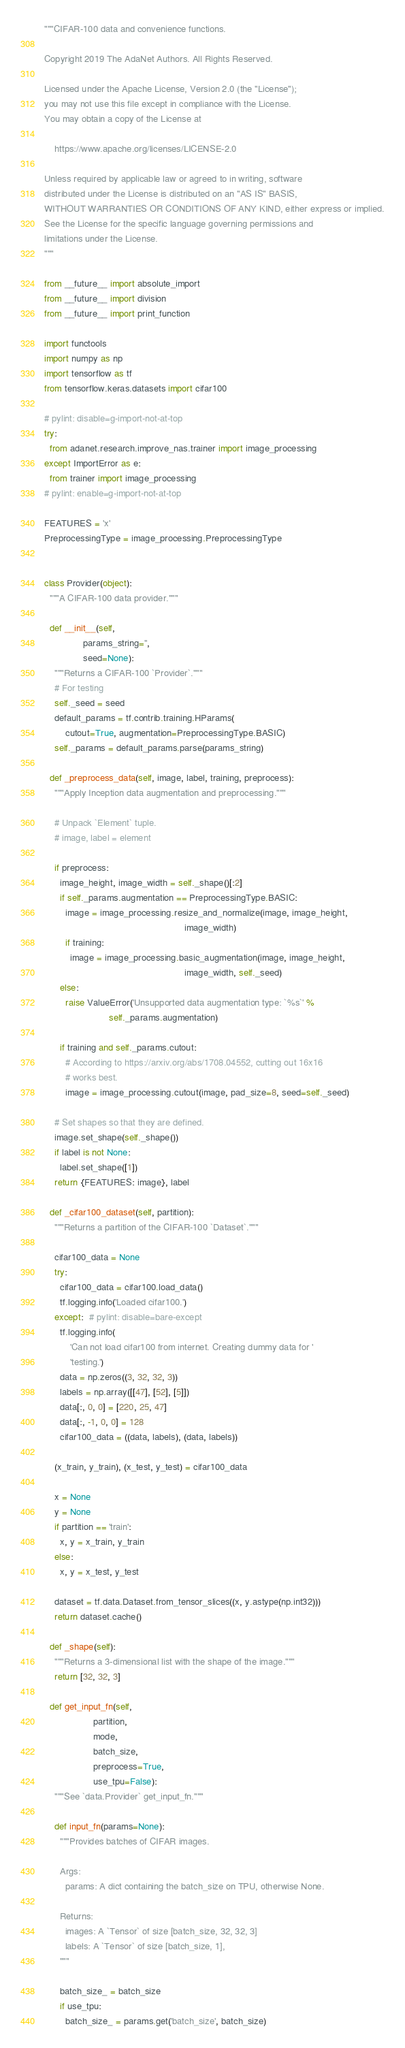<code> <loc_0><loc_0><loc_500><loc_500><_Python_>"""CIFAR-100 data and convenience functions.

Copyright 2019 The AdaNet Authors. All Rights Reserved.

Licensed under the Apache License, Version 2.0 (the "License");
you may not use this file except in compliance with the License.
You may obtain a copy of the License at

    https://www.apache.org/licenses/LICENSE-2.0

Unless required by applicable law or agreed to in writing, software
distributed under the License is distributed on an "AS IS" BASIS,
WITHOUT WARRANTIES OR CONDITIONS OF ANY KIND, either express or implied.
See the License for the specific language governing permissions and
limitations under the License.
"""

from __future__ import absolute_import
from __future__ import division
from __future__ import print_function

import functools
import numpy as np
import tensorflow as tf
from tensorflow.keras.datasets import cifar100

# pylint: disable=g-import-not-at-top
try:
  from adanet.research.improve_nas.trainer import image_processing
except ImportError as e:
  from trainer import image_processing
# pylint: enable=g-import-not-at-top

FEATURES = 'x'
PreprocessingType = image_processing.PreprocessingType


class Provider(object):
  """A CIFAR-100 data provider."""

  def __init__(self,
               params_string='',
               seed=None):
    """Returns a CIFAR-100 `Provider`."""
    # For testing
    self._seed = seed
    default_params = tf.contrib.training.HParams(
        cutout=True, augmentation=PreprocessingType.BASIC)
    self._params = default_params.parse(params_string)

  def _preprocess_data(self, image, label, training, preprocess):
    """Apply Inception data augmentation and preprocessing."""

    # Unpack `Element` tuple.
    # image, label = element

    if preprocess:
      image_height, image_width = self._shape()[:2]
      if self._params.augmentation == PreprocessingType.BASIC:
        image = image_processing.resize_and_normalize(image, image_height,
                                                      image_width)
        if training:
          image = image_processing.basic_augmentation(image, image_height,
                                                      image_width, self._seed)
      else:
        raise ValueError('Unsupported data augmentation type: `%s`' %
                         self._params.augmentation)

      if training and self._params.cutout:
        # According to https://arxiv.org/abs/1708.04552, cutting out 16x16
        # works best.
        image = image_processing.cutout(image, pad_size=8, seed=self._seed)

    # Set shapes so that they are defined.
    image.set_shape(self._shape())
    if label is not None:
      label.set_shape([1])
    return {FEATURES: image}, label

  def _cifar100_dataset(self, partition):
    """Returns a partition of the CIFAR-100 `Dataset`."""

    cifar100_data = None
    try:
      cifar100_data = cifar100.load_data()
      tf.logging.info('Loaded cifar100.')
    except:  # pylint: disable=bare-except
      tf.logging.info(
          'Can not load cifar100 from internet. Creating dummy data for '
          'testing.')
      data = np.zeros((3, 32, 32, 3))
      labels = np.array([[47], [52], [5]])
      data[:, 0, 0] = [220, 25, 47]
      data[:, -1, 0, 0] = 128
      cifar100_data = ((data, labels), (data, labels))

    (x_train, y_train), (x_test, y_test) = cifar100_data

    x = None
    y = None
    if partition == 'train':
      x, y = x_train, y_train
    else:
      x, y = x_test, y_test

    dataset = tf.data.Dataset.from_tensor_slices((x, y.astype(np.int32)))
    return dataset.cache()

  def _shape(self):
    """Returns a 3-dimensional list with the shape of the image."""
    return [32, 32, 3]

  def get_input_fn(self,
                   partition,
                   mode,
                   batch_size,
                   preprocess=True,
                   use_tpu=False):
    """See `data.Provider` get_input_fn."""

    def input_fn(params=None):
      """Provides batches of CIFAR images.

      Args:
        params: A dict containing the batch_size on TPU, otherwise None.

      Returns:
        images: A `Tensor` of size [batch_size, 32, 32, 3]
        labels: A `Tensor` of size [batch_size, 1],
      """

      batch_size_ = batch_size
      if use_tpu:
        batch_size_ = params.get('batch_size', batch_size)
</code> 